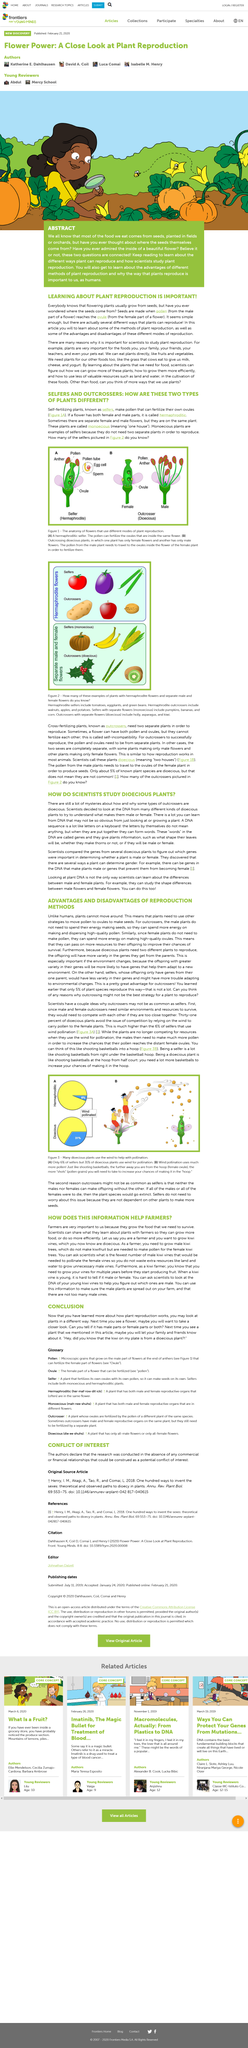Mention a couple of crucial points in this snapshot. No, plant DNA is not the only way to determine differences between male and female flowers. The flowers that possess both male and female reproductive parts are referred to as hermaphroditic flowers. According to a recent study, approximately 31% of dioecious plants rely on wind for pollination. The word 'monoecious' means one house. Specifically, it refers to a plant that has both male and female reproductive parts, or houses, on the same plant. Self-fertilizing plants, also known as selfers, are recognized by their method of reproduction where they fertilize themselves without the need for pollination from another plant. 